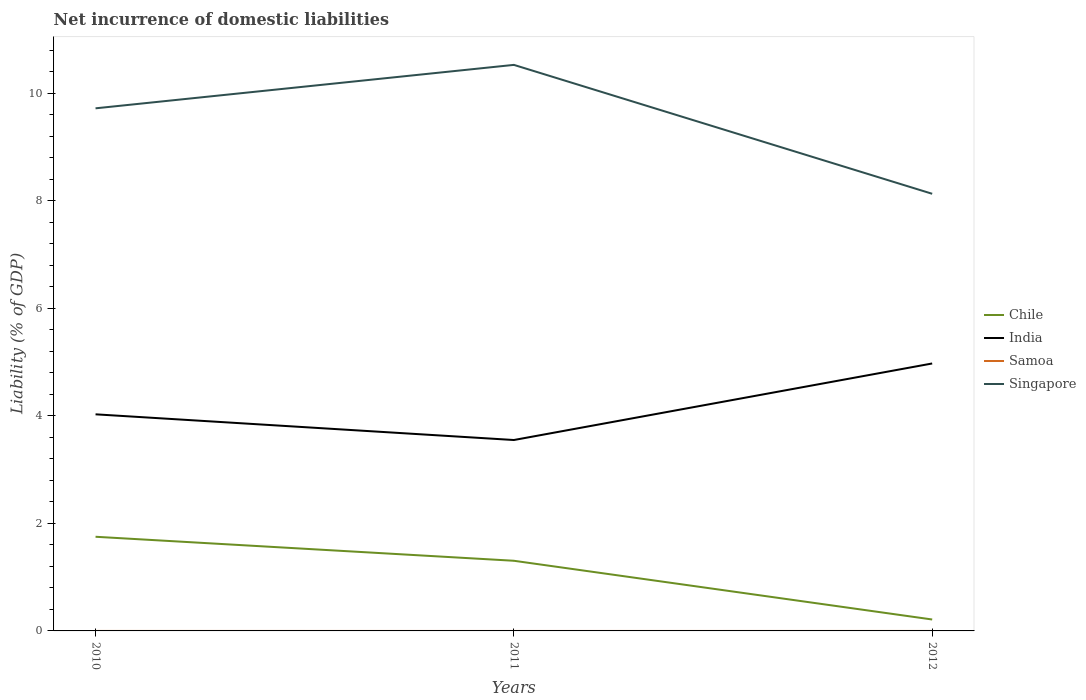How many different coloured lines are there?
Give a very brief answer. 3. Across all years, what is the maximum net incurrence of domestic liabilities in Singapore?
Your answer should be compact. 8.13. What is the total net incurrence of domestic liabilities in India in the graph?
Your answer should be compact. -0.95. What is the difference between the highest and the second highest net incurrence of domestic liabilities in India?
Offer a very short reply. 1.42. What is the difference between the highest and the lowest net incurrence of domestic liabilities in India?
Provide a succinct answer. 1. Is the net incurrence of domestic liabilities in Singapore strictly greater than the net incurrence of domestic liabilities in India over the years?
Provide a short and direct response. No. How many legend labels are there?
Your response must be concise. 4. What is the title of the graph?
Offer a terse response. Net incurrence of domestic liabilities. Does "Uganda" appear as one of the legend labels in the graph?
Make the answer very short. No. What is the label or title of the X-axis?
Offer a very short reply. Years. What is the label or title of the Y-axis?
Your response must be concise. Liability (% of GDP). What is the Liability (% of GDP) in Chile in 2010?
Offer a terse response. 1.75. What is the Liability (% of GDP) of India in 2010?
Your answer should be very brief. 4.03. What is the Liability (% of GDP) of Singapore in 2010?
Ensure brevity in your answer.  9.72. What is the Liability (% of GDP) in Chile in 2011?
Give a very brief answer. 1.3. What is the Liability (% of GDP) of India in 2011?
Give a very brief answer. 3.55. What is the Liability (% of GDP) in Samoa in 2011?
Your answer should be very brief. 0. What is the Liability (% of GDP) in Singapore in 2011?
Give a very brief answer. 10.53. What is the Liability (% of GDP) of Chile in 2012?
Offer a terse response. 0.21. What is the Liability (% of GDP) of India in 2012?
Provide a succinct answer. 4.97. What is the Liability (% of GDP) in Singapore in 2012?
Ensure brevity in your answer.  8.13. Across all years, what is the maximum Liability (% of GDP) in Chile?
Keep it short and to the point. 1.75. Across all years, what is the maximum Liability (% of GDP) in India?
Give a very brief answer. 4.97. Across all years, what is the maximum Liability (% of GDP) in Singapore?
Keep it short and to the point. 10.53. Across all years, what is the minimum Liability (% of GDP) in Chile?
Keep it short and to the point. 0.21. Across all years, what is the minimum Liability (% of GDP) in India?
Ensure brevity in your answer.  3.55. Across all years, what is the minimum Liability (% of GDP) of Singapore?
Ensure brevity in your answer.  8.13. What is the total Liability (% of GDP) in Chile in the graph?
Make the answer very short. 3.27. What is the total Liability (% of GDP) of India in the graph?
Keep it short and to the point. 12.55. What is the total Liability (% of GDP) in Singapore in the graph?
Make the answer very short. 28.38. What is the difference between the Liability (% of GDP) of Chile in 2010 and that in 2011?
Your answer should be very brief. 0.45. What is the difference between the Liability (% of GDP) in India in 2010 and that in 2011?
Your response must be concise. 0.48. What is the difference between the Liability (% of GDP) in Singapore in 2010 and that in 2011?
Keep it short and to the point. -0.81. What is the difference between the Liability (% of GDP) in Chile in 2010 and that in 2012?
Offer a very short reply. 1.54. What is the difference between the Liability (% of GDP) of India in 2010 and that in 2012?
Give a very brief answer. -0.95. What is the difference between the Liability (% of GDP) of Singapore in 2010 and that in 2012?
Your response must be concise. 1.59. What is the difference between the Liability (% of GDP) of Chile in 2011 and that in 2012?
Provide a short and direct response. 1.09. What is the difference between the Liability (% of GDP) in India in 2011 and that in 2012?
Make the answer very short. -1.42. What is the difference between the Liability (% of GDP) in Singapore in 2011 and that in 2012?
Offer a terse response. 2.4. What is the difference between the Liability (% of GDP) in Chile in 2010 and the Liability (% of GDP) in India in 2011?
Offer a very short reply. -1.8. What is the difference between the Liability (% of GDP) of Chile in 2010 and the Liability (% of GDP) of Singapore in 2011?
Make the answer very short. -8.78. What is the difference between the Liability (% of GDP) of India in 2010 and the Liability (% of GDP) of Singapore in 2011?
Your answer should be very brief. -6.5. What is the difference between the Liability (% of GDP) in Chile in 2010 and the Liability (% of GDP) in India in 2012?
Provide a short and direct response. -3.22. What is the difference between the Liability (% of GDP) of Chile in 2010 and the Liability (% of GDP) of Singapore in 2012?
Offer a very short reply. -6.38. What is the difference between the Liability (% of GDP) of India in 2010 and the Liability (% of GDP) of Singapore in 2012?
Your answer should be compact. -4.1. What is the difference between the Liability (% of GDP) of Chile in 2011 and the Liability (% of GDP) of India in 2012?
Your response must be concise. -3.67. What is the difference between the Liability (% of GDP) of Chile in 2011 and the Liability (% of GDP) of Singapore in 2012?
Keep it short and to the point. -6.83. What is the difference between the Liability (% of GDP) in India in 2011 and the Liability (% of GDP) in Singapore in 2012?
Give a very brief answer. -4.58. What is the average Liability (% of GDP) in Chile per year?
Keep it short and to the point. 1.09. What is the average Liability (% of GDP) of India per year?
Offer a terse response. 4.18. What is the average Liability (% of GDP) of Samoa per year?
Make the answer very short. 0. What is the average Liability (% of GDP) in Singapore per year?
Offer a terse response. 9.46. In the year 2010, what is the difference between the Liability (% of GDP) of Chile and Liability (% of GDP) of India?
Offer a terse response. -2.28. In the year 2010, what is the difference between the Liability (% of GDP) in Chile and Liability (% of GDP) in Singapore?
Your response must be concise. -7.97. In the year 2010, what is the difference between the Liability (% of GDP) of India and Liability (% of GDP) of Singapore?
Ensure brevity in your answer.  -5.69. In the year 2011, what is the difference between the Liability (% of GDP) of Chile and Liability (% of GDP) of India?
Your response must be concise. -2.25. In the year 2011, what is the difference between the Liability (% of GDP) of Chile and Liability (% of GDP) of Singapore?
Make the answer very short. -9.22. In the year 2011, what is the difference between the Liability (% of GDP) of India and Liability (% of GDP) of Singapore?
Offer a very short reply. -6.98. In the year 2012, what is the difference between the Liability (% of GDP) of Chile and Liability (% of GDP) of India?
Ensure brevity in your answer.  -4.76. In the year 2012, what is the difference between the Liability (% of GDP) of Chile and Liability (% of GDP) of Singapore?
Your answer should be compact. -7.92. In the year 2012, what is the difference between the Liability (% of GDP) of India and Liability (% of GDP) of Singapore?
Offer a very short reply. -3.16. What is the ratio of the Liability (% of GDP) of Chile in 2010 to that in 2011?
Ensure brevity in your answer.  1.34. What is the ratio of the Liability (% of GDP) of India in 2010 to that in 2011?
Make the answer very short. 1.13. What is the ratio of the Liability (% of GDP) of Singapore in 2010 to that in 2011?
Provide a succinct answer. 0.92. What is the ratio of the Liability (% of GDP) of Chile in 2010 to that in 2012?
Your response must be concise. 8.24. What is the ratio of the Liability (% of GDP) of India in 2010 to that in 2012?
Provide a succinct answer. 0.81. What is the ratio of the Liability (% of GDP) in Singapore in 2010 to that in 2012?
Make the answer very short. 1.2. What is the ratio of the Liability (% of GDP) of Chile in 2011 to that in 2012?
Keep it short and to the point. 6.14. What is the ratio of the Liability (% of GDP) of India in 2011 to that in 2012?
Give a very brief answer. 0.71. What is the ratio of the Liability (% of GDP) of Singapore in 2011 to that in 2012?
Offer a terse response. 1.29. What is the difference between the highest and the second highest Liability (% of GDP) in Chile?
Offer a very short reply. 0.45. What is the difference between the highest and the second highest Liability (% of GDP) in India?
Keep it short and to the point. 0.95. What is the difference between the highest and the second highest Liability (% of GDP) in Singapore?
Offer a terse response. 0.81. What is the difference between the highest and the lowest Liability (% of GDP) in Chile?
Provide a succinct answer. 1.54. What is the difference between the highest and the lowest Liability (% of GDP) in India?
Keep it short and to the point. 1.42. What is the difference between the highest and the lowest Liability (% of GDP) in Singapore?
Make the answer very short. 2.4. 